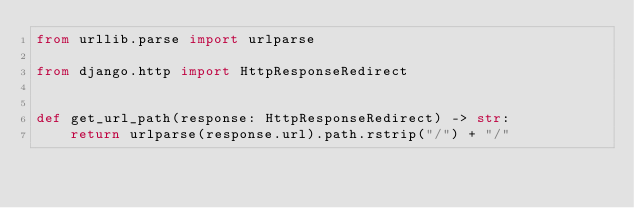Convert code to text. <code><loc_0><loc_0><loc_500><loc_500><_Python_>from urllib.parse import urlparse

from django.http import HttpResponseRedirect


def get_url_path(response: HttpResponseRedirect) -> str:
    return urlparse(response.url).path.rstrip("/") + "/"
</code> 